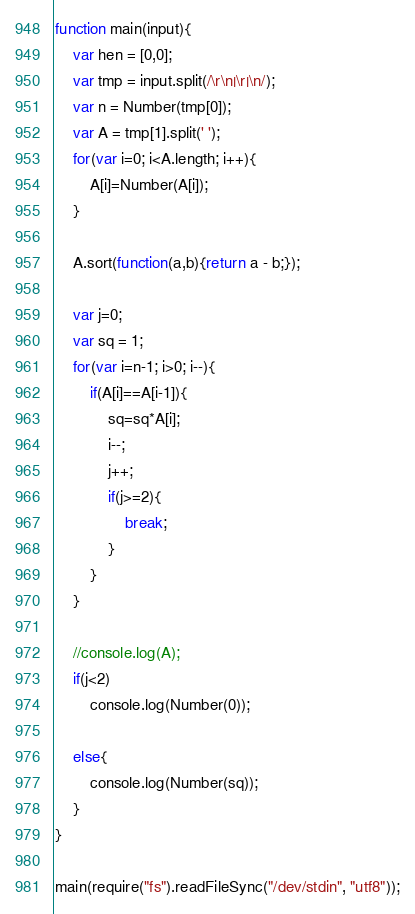Convert code to text. <code><loc_0><loc_0><loc_500><loc_500><_JavaScript_>function main(input){
    var hen = [0,0];
    var tmp = input.split(/\r\n|\r|\n/);
    var n = Number(tmp[0]);
    var A = tmp[1].split(' ');
    for(var i=0; i<A.length; i++){
        A[i]=Number(A[i]);
    }

    A.sort(function(a,b){return a - b;});

    var j=0;
    var sq = 1;
    for(var i=n-1; i>0; i--){
        if(A[i]==A[i-1]){
            sq=sq*A[i];
            i--;
            j++;
            if(j>=2){
                break;
            }
        }
    }

    //console.log(A);
    if(j<2)
        console.log(Number(0));

    else{
        console.log(Number(sq));
    }
}

main(require("fs").readFileSync("/dev/stdin", "utf8"));</code> 